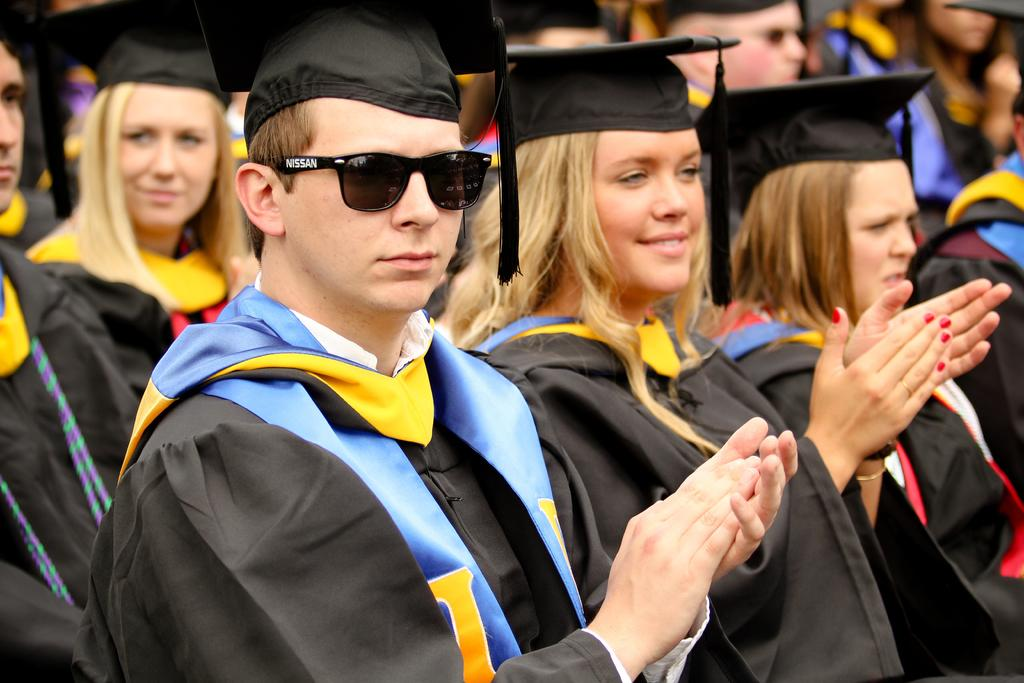How many people are in the image? There are people standing in the image. Can you describe any specific clothing or accessories worn by the people? One person is wearing goggles. What type of waste is being disposed of in the image? There is no waste present in the image; it features people standing, with one person wearing goggles. 